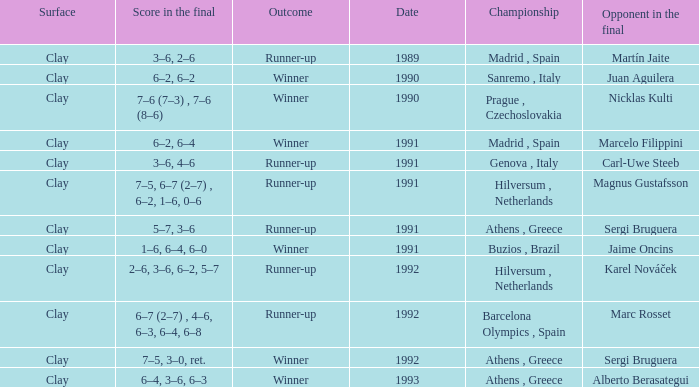What is Score In The Final, when Championship is "Athens , Greece", and when Outcome is "Winner"? 7–5, 3–0, ret., 6–4, 3–6, 6–3. 